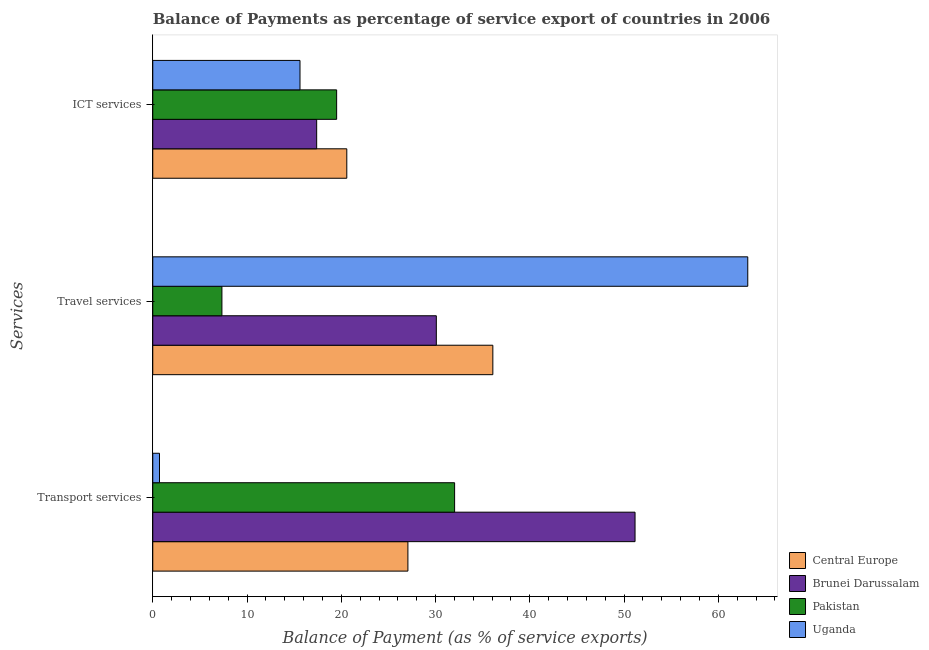Are the number of bars per tick equal to the number of legend labels?
Provide a succinct answer. Yes. Are the number of bars on each tick of the Y-axis equal?
Your answer should be very brief. Yes. How many bars are there on the 2nd tick from the top?
Keep it short and to the point. 4. How many bars are there on the 1st tick from the bottom?
Give a very brief answer. 4. What is the label of the 1st group of bars from the top?
Your response must be concise. ICT services. What is the balance of payment of ict services in Central Europe?
Make the answer very short. 20.58. Across all countries, what is the maximum balance of payment of transport services?
Your response must be concise. 51.16. Across all countries, what is the minimum balance of payment of travel services?
Offer a terse response. 7.34. In which country was the balance of payment of travel services maximum?
Provide a succinct answer. Uganda. In which country was the balance of payment of transport services minimum?
Your response must be concise. Uganda. What is the total balance of payment of travel services in the graph?
Your answer should be compact. 136.61. What is the difference between the balance of payment of ict services in Brunei Darussalam and that in Pakistan?
Ensure brevity in your answer.  -2.12. What is the difference between the balance of payment of travel services in Brunei Darussalam and the balance of payment of transport services in Central Europe?
Make the answer very short. 3.01. What is the average balance of payment of travel services per country?
Provide a short and direct response. 34.15. What is the difference between the balance of payment of ict services and balance of payment of travel services in Central Europe?
Provide a succinct answer. -15.49. What is the ratio of the balance of payment of ict services in Pakistan to that in Uganda?
Provide a short and direct response. 1.25. Is the difference between the balance of payment of ict services in Brunei Darussalam and Central Europe greater than the difference between the balance of payment of transport services in Brunei Darussalam and Central Europe?
Ensure brevity in your answer.  No. What is the difference between the highest and the second highest balance of payment of transport services?
Your response must be concise. 19.14. What is the difference between the highest and the lowest balance of payment of ict services?
Give a very brief answer. 4.96. In how many countries, is the balance of payment of transport services greater than the average balance of payment of transport services taken over all countries?
Provide a succinct answer. 2. What does the 4th bar from the top in ICT services represents?
Keep it short and to the point. Central Europe. What does the 1st bar from the bottom in ICT services represents?
Provide a succinct answer. Central Europe. How many bars are there?
Offer a terse response. 12. How many countries are there in the graph?
Ensure brevity in your answer.  4. What is the difference between two consecutive major ticks on the X-axis?
Provide a succinct answer. 10. Does the graph contain grids?
Give a very brief answer. No. Where does the legend appear in the graph?
Give a very brief answer. Bottom right. How many legend labels are there?
Ensure brevity in your answer.  4. How are the legend labels stacked?
Give a very brief answer. Vertical. What is the title of the graph?
Offer a very short reply. Balance of Payments as percentage of service export of countries in 2006. Does "Malawi" appear as one of the legend labels in the graph?
Ensure brevity in your answer.  No. What is the label or title of the X-axis?
Your answer should be very brief. Balance of Payment (as % of service exports). What is the label or title of the Y-axis?
Make the answer very short. Services. What is the Balance of Payment (as % of service exports) of Central Europe in Transport services?
Give a very brief answer. 27.07. What is the Balance of Payment (as % of service exports) in Brunei Darussalam in Transport services?
Offer a very short reply. 51.16. What is the Balance of Payment (as % of service exports) in Pakistan in Transport services?
Make the answer very short. 32.02. What is the Balance of Payment (as % of service exports) in Uganda in Transport services?
Your answer should be compact. 0.71. What is the Balance of Payment (as % of service exports) in Central Europe in Travel services?
Your answer should be very brief. 36.08. What is the Balance of Payment (as % of service exports) of Brunei Darussalam in Travel services?
Your answer should be compact. 30.08. What is the Balance of Payment (as % of service exports) of Pakistan in Travel services?
Make the answer very short. 7.34. What is the Balance of Payment (as % of service exports) of Uganda in Travel services?
Keep it short and to the point. 63.12. What is the Balance of Payment (as % of service exports) of Central Europe in ICT services?
Your response must be concise. 20.58. What is the Balance of Payment (as % of service exports) in Brunei Darussalam in ICT services?
Your answer should be very brief. 17.39. What is the Balance of Payment (as % of service exports) in Pakistan in ICT services?
Offer a terse response. 19.51. What is the Balance of Payment (as % of service exports) of Uganda in ICT services?
Your response must be concise. 15.62. Across all Services, what is the maximum Balance of Payment (as % of service exports) in Central Europe?
Your answer should be compact. 36.08. Across all Services, what is the maximum Balance of Payment (as % of service exports) in Brunei Darussalam?
Make the answer very short. 51.16. Across all Services, what is the maximum Balance of Payment (as % of service exports) of Pakistan?
Your response must be concise. 32.02. Across all Services, what is the maximum Balance of Payment (as % of service exports) in Uganda?
Make the answer very short. 63.12. Across all Services, what is the minimum Balance of Payment (as % of service exports) in Central Europe?
Provide a short and direct response. 20.58. Across all Services, what is the minimum Balance of Payment (as % of service exports) in Brunei Darussalam?
Offer a very short reply. 17.39. Across all Services, what is the minimum Balance of Payment (as % of service exports) of Pakistan?
Offer a terse response. 7.34. Across all Services, what is the minimum Balance of Payment (as % of service exports) of Uganda?
Your answer should be compact. 0.71. What is the total Balance of Payment (as % of service exports) of Central Europe in the graph?
Your answer should be very brief. 83.73. What is the total Balance of Payment (as % of service exports) in Brunei Darussalam in the graph?
Offer a very short reply. 98.63. What is the total Balance of Payment (as % of service exports) of Pakistan in the graph?
Keep it short and to the point. 58.86. What is the total Balance of Payment (as % of service exports) in Uganda in the graph?
Keep it short and to the point. 79.45. What is the difference between the Balance of Payment (as % of service exports) of Central Europe in Transport services and that in Travel services?
Offer a very short reply. -9.01. What is the difference between the Balance of Payment (as % of service exports) of Brunei Darussalam in Transport services and that in Travel services?
Offer a terse response. 21.08. What is the difference between the Balance of Payment (as % of service exports) of Pakistan in Transport services and that in Travel services?
Make the answer very short. 24.68. What is the difference between the Balance of Payment (as % of service exports) of Uganda in Transport services and that in Travel services?
Your response must be concise. -62.41. What is the difference between the Balance of Payment (as % of service exports) in Central Europe in Transport services and that in ICT services?
Your answer should be very brief. 6.48. What is the difference between the Balance of Payment (as % of service exports) in Brunei Darussalam in Transport services and that in ICT services?
Your answer should be very brief. 33.77. What is the difference between the Balance of Payment (as % of service exports) in Pakistan in Transport services and that in ICT services?
Your answer should be very brief. 12.51. What is the difference between the Balance of Payment (as % of service exports) of Uganda in Transport services and that in ICT services?
Your answer should be compact. -14.91. What is the difference between the Balance of Payment (as % of service exports) in Central Europe in Travel services and that in ICT services?
Offer a terse response. 15.49. What is the difference between the Balance of Payment (as % of service exports) in Brunei Darussalam in Travel services and that in ICT services?
Make the answer very short. 12.69. What is the difference between the Balance of Payment (as % of service exports) in Pakistan in Travel services and that in ICT services?
Give a very brief answer. -12.17. What is the difference between the Balance of Payment (as % of service exports) in Uganda in Travel services and that in ICT services?
Offer a terse response. 47.5. What is the difference between the Balance of Payment (as % of service exports) in Central Europe in Transport services and the Balance of Payment (as % of service exports) in Brunei Darussalam in Travel services?
Make the answer very short. -3.01. What is the difference between the Balance of Payment (as % of service exports) of Central Europe in Transport services and the Balance of Payment (as % of service exports) of Pakistan in Travel services?
Provide a succinct answer. 19.73. What is the difference between the Balance of Payment (as % of service exports) of Central Europe in Transport services and the Balance of Payment (as % of service exports) of Uganda in Travel services?
Make the answer very short. -36.05. What is the difference between the Balance of Payment (as % of service exports) in Brunei Darussalam in Transport services and the Balance of Payment (as % of service exports) in Pakistan in Travel services?
Offer a terse response. 43.82. What is the difference between the Balance of Payment (as % of service exports) of Brunei Darussalam in Transport services and the Balance of Payment (as % of service exports) of Uganda in Travel services?
Give a very brief answer. -11.96. What is the difference between the Balance of Payment (as % of service exports) in Pakistan in Transport services and the Balance of Payment (as % of service exports) in Uganda in Travel services?
Your response must be concise. -31.1. What is the difference between the Balance of Payment (as % of service exports) in Central Europe in Transport services and the Balance of Payment (as % of service exports) in Brunei Darussalam in ICT services?
Your answer should be compact. 9.68. What is the difference between the Balance of Payment (as % of service exports) of Central Europe in Transport services and the Balance of Payment (as % of service exports) of Pakistan in ICT services?
Make the answer very short. 7.56. What is the difference between the Balance of Payment (as % of service exports) in Central Europe in Transport services and the Balance of Payment (as % of service exports) in Uganda in ICT services?
Give a very brief answer. 11.45. What is the difference between the Balance of Payment (as % of service exports) in Brunei Darussalam in Transport services and the Balance of Payment (as % of service exports) in Pakistan in ICT services?
Provide a short and direct response. 31.66. What is the difference between the Balance of Payment (as % of service exports) of Brunei Darussalam in Transport services and the Balance of Payment (as % of service exports) of Uganda in ICT services?
Your answer should be very brief. 35.54. What is the difference between the Balance of Payment (as % of service exports) of Pakistan in Transport services and the Balance of Payment (as % of service exports) of Uganda in ICT services?
Give a very brief answer. 16.4. What is the difference between the Balance of Payment (as % of service exports) in Central Europe in Travel services and the Balance of Payment (as % of service exports) in Brunei Darussalam in ICT services?
Your response must be concise. 18.69. What is the difference between the Balance of Payment (as % of service exports) in Central Europe in Travel services and the Balance of Payment (as % of service exports) in Pakistan in ICT services?
Provide a short and direct response. 16.57. What is the difference between the Balance of Payment (as % of service exports) in Central Europe in Travel services and the Balance of Payment (as % of service exports) in Uganda in ICT services?
Provide a short and direct response. 20.46. What is the difference between the Balance of Payment (as % of service exports) in Brunei Darussalam in Travel services and the Balance of Payment (as % of service exports) in Pakistan in ICT services?
Your answer should be compact. 10.57. What is the difference between the Balance of Payment (as % of service exports) in Brunei Darussalam in Travel services and the Balance of Payment (as % of service exports) in Uganda in ICT services?
Keep it short and to the point. 14.46. What is the difference between the Balance of Payment (as % of service exports) in Pakistan in Travel services and the Balance of Payment (as % of service exports) in Uganda in ICT services?
Your answer should be compact. -8.28. What is the average Balance of Payment (as % of service exports) of Central Europe per Services?
Provide a short and direct response. 27.91. What is the average Balance of Payment (as % of service exports) in Brunei Darussalam per Services?
Give a very brief answer. 32.88. What is the average Balance of Payment (as % of service exports) of Pakistan per Services?
Offer a very short reply. 19.62. What is the average Balance of Payment (as % of service exports) in Uganda per Services?
Ensure brevity in your answer.  26.48. What is the difference between the Balance of Payment (as % of service exports) in Central Europe and Balance of Payment (as % of service exports) in Brunei Darussalam in Transport services?
Give a very brief answer. -24.1. What is the difference between the Balance of Payment (as % of service exports) of Central Europe and Balance of Payment (as % of service exports) of Pakistan in Transport services?
Your response must be concise. -4.95. What is the difference between the Balance of Payment (as % of service exports) of Central Europe and Balance of Payment (as % of service exports) of Uganda in Transport services?
Give a very brief answer. 26.35. What is the difference between the Balance of Payment (as % of service exports) of Brunei Darussalam and Balance of Payment (as % of service exports) of Pakistan in Transport services?
Your response must be concise. 19.14. What is the difference between the Balance of Payment (as % of service exports) in Brunei Darussalam and Balance of Payment (as % of service exports) in Uganda in Transport services?
Provide a succinct answer. 50.45. What is the difference between the Balance of Payment (as % of service exports) in Pakistan and Balance of Payment (as % of service exports) in Uganda in Transport services?
Give a very brief answer. 31.31. What is the difference between the Balance of Payment (as % of service exports) in Central Europe and Balance of Payment (as % of service exports) in Brunei Darussalam in Travel services?
Your answer should be compact. 6. What is the difference between the Balance of Payment (as % of service exports) of Central Europe and Balance of Payment (as % of service exports) of Pakistan in Travel services?
Your answer should be compact. 28.74. What is the difference between the Balance of Payment (as % of service exports) of Central Europe and Balance of Payment (as % of service exports) of Uganda in Travel services?
Provide a short and direct response. -27.04. What is the difference between the Balance of Payment (as % of service exports) of Brunei Darussalam and Balance of Payment (as % of service exports) of Pakistan in Travel services?
Make the answer very short. 22.74. What is the difference between the Balance of Payment (as % of service exports) in Brunei Darussalam and Balance of Payment (as % of service exports) in Uganda in Travel services?
Your response must be concise. -33.04. What is the difference between the Balance of Payment (as % of service exports) in Pakistan and Balance of Payment (as % of service exports) in Uganda in Travel services?
Keep it short and to the point. -55.78. What is the difference between the Balance of Payment (as % of service exports) of Central Europe and Balance of Payment (as % of service exports) of Brunei Darussalam in ICT services?
Keep it short and to the point. 3.2. What is the difference between the Balance of Payment (as % of service exports) in Central Europe and Balance of Payment (as % of service exports) in Pakistan in ICT services?
Your response must be concise. 1.08. What is the difference between the Balance of Payment (as % of service exports) of Central Europe and Balance of Payment (as % of service exports) of Uganda in ICT services?
Give a very brief answer. 4.96. What is the difference between the Balance of Payment (as % of service exports) in Brunei Darussalam and Balance of Payment (as % of service exports) in Pakistan in ICT services?
Your answer should be compact. -2.12. What is the difference between the Balance of Payment (as % of service exports) in Brunei Darussalam and Balance of Payment (as % of service exports) in Uganda in ICT services?
Offer a terse response. 1.77. What is the difference between the Balance of Payment (as % of service exports) of Pakistan and Balance of Payment (as % of service exports) of Uganda in ICT services?
Offer a very short reply. 3.89. What is the ratio of the Balance of Payment (as % of service exports) in Central Europe in Transport services to that in Travel services?
Ensure brevity in your answer.  0.75. What is the ratio of the Balance of Payment (as % of service exports) in Brunei Darussalam in Transport services to that in Travel services?
Give a very brief answer. 1.7. What is the ratio of the Balance of Payment (as % of service exports) of Pakistan in Transport services to that in Travel services?
Keep it short and to the point. 4.36. What is the ratio of the Balance of Payment (as % of service exports) in Uganda in Transport services to that in Travel services?
Your answer should be compact. 0.01. What is the ratio of the Balance of Payment (as % of service exports) in Central Europe in Transport services to that in ICT services?
Make the answer very short. 1.31. What is the ratio of the Balance of Payment (as % of service exports) in Brunei Darussalam in Transport services to that in ICT services?
Provide a short and direct response. 2.94. What is the ratio of the Balance of Payment (as % of service exports) of Pakistan in Transport services to that in ICT services?
Offer a terse response. 1.64. What is the ratio of the Balance of Payment (as % of service exports) of Uganda in Transport services to that in ICT services?
Your answer should be compact. 0.05. What is the ratio of the Balance of Payment (as % of service exports) in Central Europe in Travel services to that in ICT services?
Your answer should be compact. 1.75. What is the ratio of the Balance of Payment (as % of service exports) of Brunei Darussalam in Travel services to that in ICT services?
Your answer should be compact. 1.73. What is the ratio of the Balance of Payment (as % of service exports) of Pakistan in Travel services to that in ICT services?
Offer a terse response. 0.38. What is the ratio of the Balance of Payment (as % of service exports) of Uganda in Travel services to that in ICT services?
Your response must be concise. 4.04. What is the difference between the highest and the second highest Balance of Payment (as % of service exports) of Central Europe?
Your response must be concise. 9.01. What is the difference between the highest and the second highest Balance of Payment (as % of service exports) in Brunei Darussalam?
Provide a succinct answer. 21.08. What is the difference between the highest and the second highest Balance of Payment (as % of service exports) in Pakistan?
Offer a terse response. 12.51. What is the difference between the highest and the second highest Balance of Payment (as % of service exports) in Uganda?
Ensure brevity in your answer.  47.5. What is the difference between the highest and the lowest Balance of Payment (as % of service exports) of Central Europe?
Provide a short and direct response. 15.49. What is the difference between the highest and the lowest Balance of Payment (as % of service exports) of Brunei Darussalam?
Offer a very short reply. 33.77. What is the difference between the highest and the lowest Balance of Payment (as % of service exports) of Pakistan?
Your answer should be very brief. 24.68. What is the difference between the highest and the lowest Balance of Payment (as % of service exports) in Uganda?
Offer a very short reply. 62.41. 